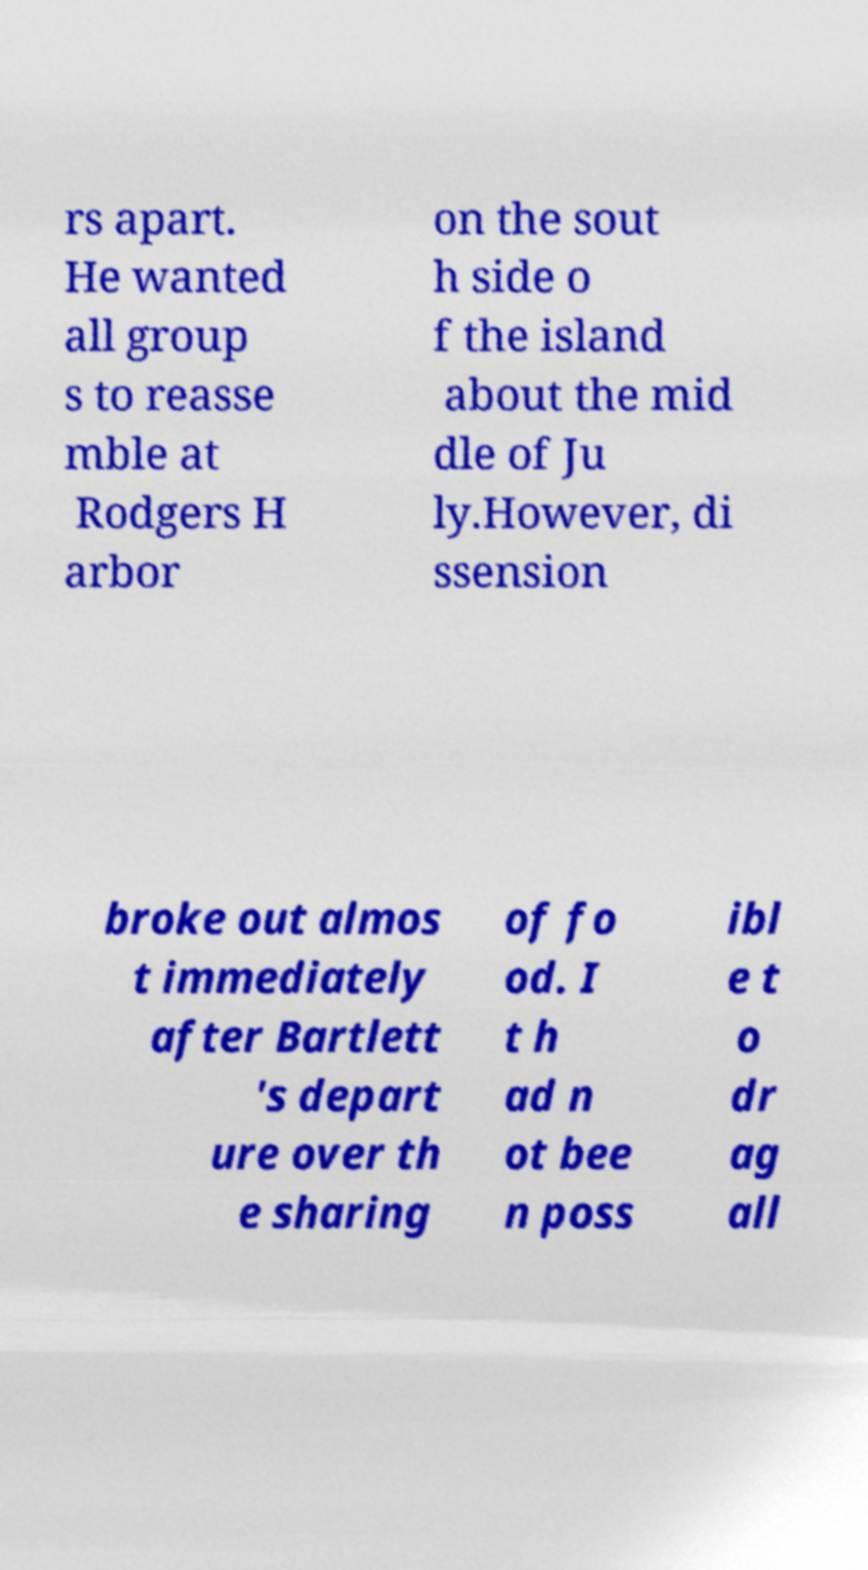Please identify and transcribe the text found in this image. rs apart. He wanted all group s to reasse mble at Rodgers H arbor on the sout h side o f the island about the mid dle of Ju ly.However, di ssension broke out almos t immediately after Bartlett 's depart ure over th e sharing of fo od. I t h ad n ot bee n poss ibl e t o dr ag all 